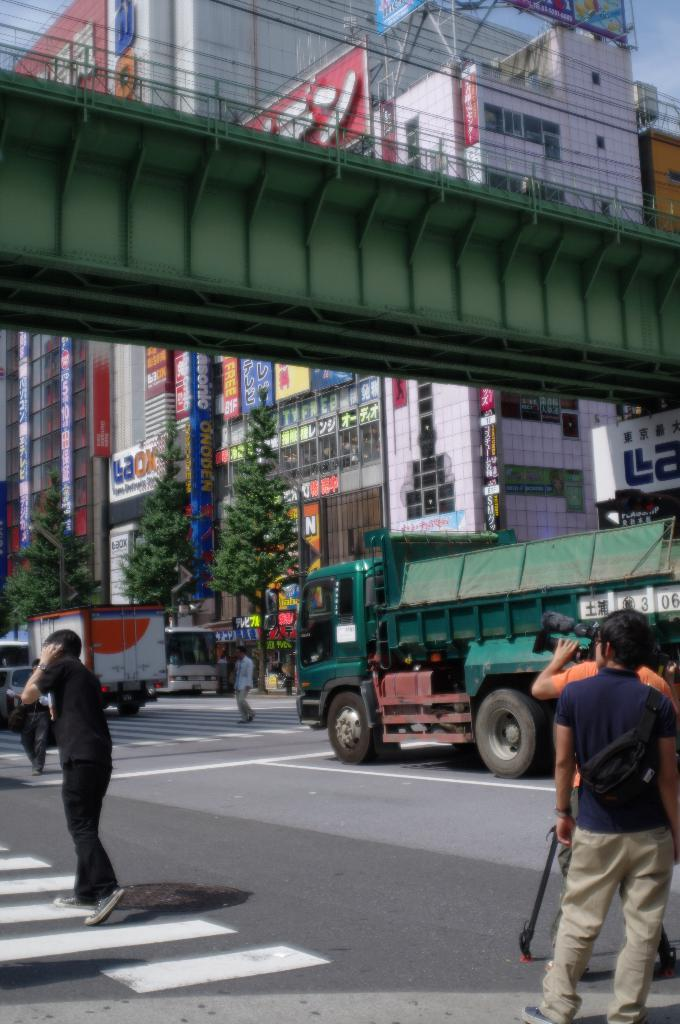What can be seen on the road in the image? There are vehicles and people on the road in the image. What is one person doing on the road? One person is holding a camera. What type of signage is visible in the image? There are boards and hoardings visible in the image. What type of vegetation is present in the image? There are trees in the image. What type of structures can be seen in the image? There are buildings and a bridge in the image. What part of the natural environment is visible in the image? The sky is visible in the image. Can you see the friends of the porter waving at the camera in the image? There is no mention of a porter or friends waving in the image. The image features vehicles, people, boards, trees, hoardings, buildings, a bridge, and the sky. 